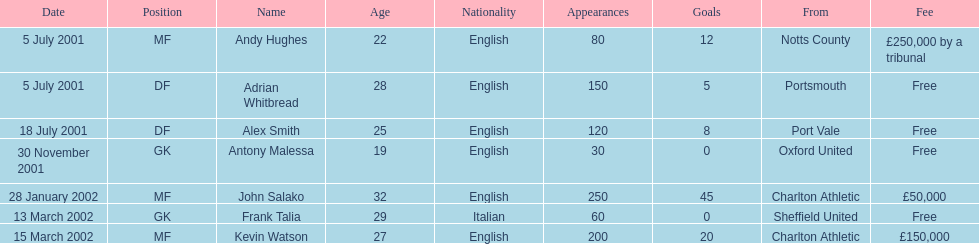Are there at least 2 nationalities on the chart? Yes. 